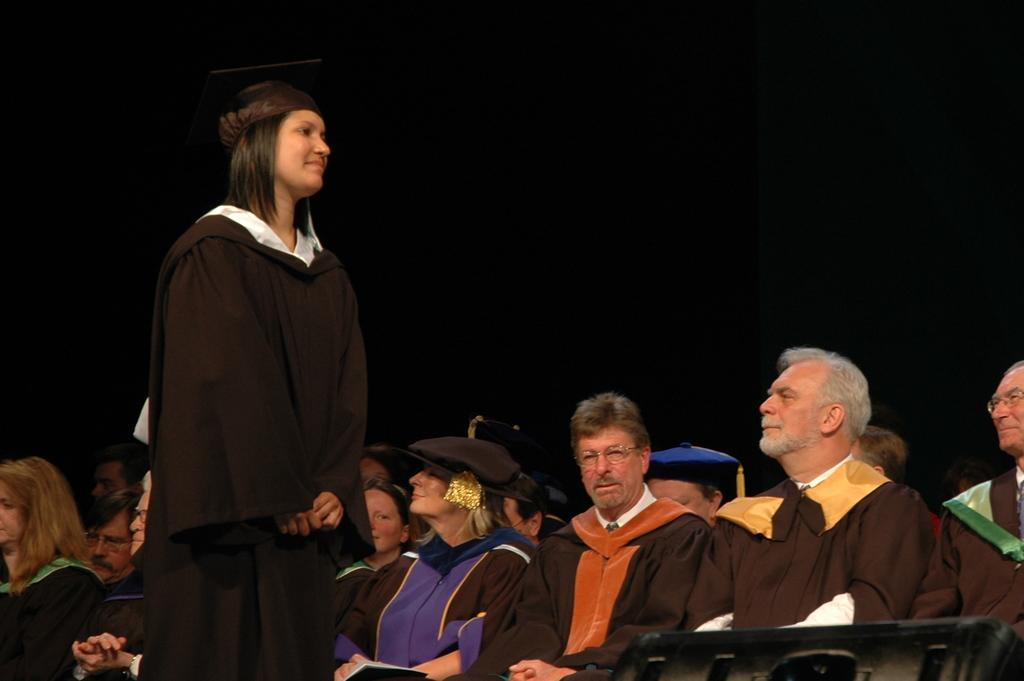What are the people in the image doing? The people in the image are sitting on chairs. Is there anyone standing in the image? Yes, there is a lady standing in the image. What color is the background of the image? The background of the image is black in color. What type of drink is the lady holding in the image? There is no drink visible in the image, as the lady is not holding anything. 